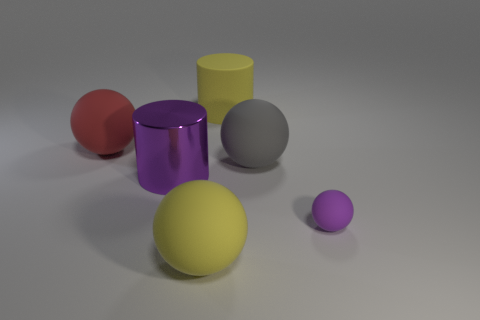Add 1 small cyan rubber balls. How many objects exist? 7 Subtract all purple spheres. How many spheres are left? 3 Subtract all purple matte balls. How many balls are left? 3 Subtract all balls. How many objects are left? 2 Add 4 large yellow matte balls. How many large yellow matte balls are left? 5 Add 1 balls. How many balls exist? 5 Subtract 0 green blocks. How many objects are left? 6 Subtract 2 cylinders. How many cylinders are left? 0 Subtract all brown spheres. Subtract all blue blocks. How many spheres are left? 4 Subtract all red spheres. How many purple cylinders are left? 1 